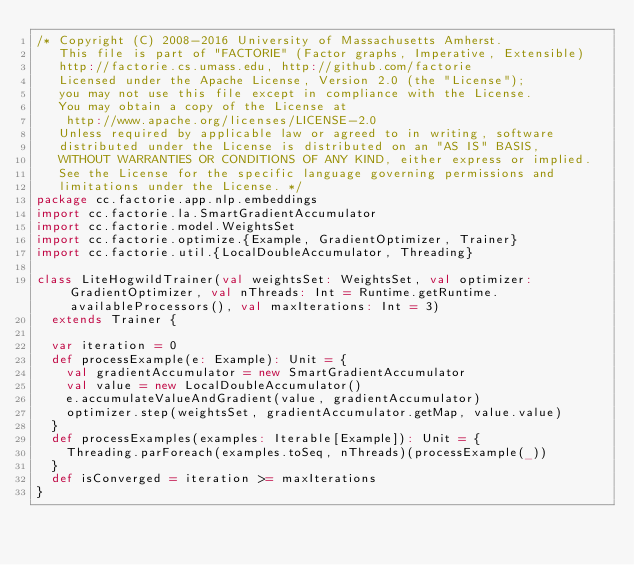<code> <loc_0><loc_0><loc_500><loc_500><_Scala_>/* Copyright (C) 2008-2016 University of Massachusetts Amherst.
   This file is part of "FACTORIE" (Factor graphs, Imperative, Extensible)
   http://factorie.cs.umass.edu, http://github.com/factorie
   Licensed under the Apache License, Version 2.0 (the "License");
   you may not use this file except in compliance with the License.
   You may obtain a copy of the License at
    http://www.apache.org/licenses/LICENSE-2.0
   Unless required by applicable law or agreed to in writing, software
   distributed under the License is distributed on an "AS IS" BASIS,
   WITHOUT WARRANTIES OR CONDITIONS OF ANY KIND, either express or implied.
   See the License for the specific language governing permissions and
   limitations under the License. */
package cc.factorie.app.nlp.embeddings
import cc.factorie.la.SmartGradientAccumulator
import cc.factorie.model.WeightsSet
import cc.factorie.optimize.{Example, GradientOptimizer, Trainer}
import cc.factorie.util.{LocalDoubleAccumulator, Threading}

class LiteHogwildTrainer(val weightsSet: WeightsSet, val optimizer: GradientOptimizer, val nThreads: Int = Runtime.getRuntime.availableProcessors(), val maxIterations: Int = 3)
  extends Trainer {

  var iteration = 0
  def processExample(e: Example): Unit = {
    val gradientAccumulator = new SmartGradientAccumulator
    val value = new LocalDoubleAccumulator()
    e.accumulateValueAndGradient(value, gradientAccumulator)
    optimizer.step(weightsSet, gradientAccumulator.getMap, value.value)
  }
  def processExamples(examples: Iterable[Example]): Unit = {
    Threading.parForeach(examples.toSeq, nThreads)(processExample(_))
  }
  def isConverged = iteration >= maxIterations
}
</code> 